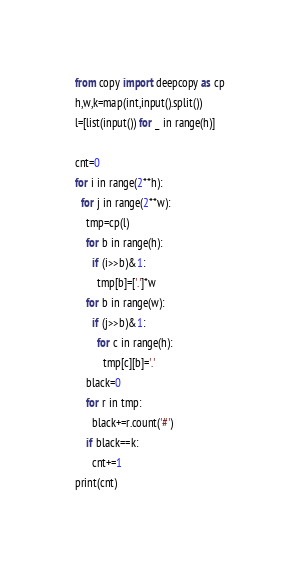Convert code to text. <code><loc_0><loc_0><loc_500><loc_500><_Python_>from copy import deepcopy as cp
h,w,k=map(int,input().split())
l=[list(input()) for _ in range(h)]

cnt=0
for i in range(2**h):
  for j in range(2**w):
    tmp=cp(l)
    for b in range(h):
      if (i>>b)&1:
        tmp[b]=['.']*w
    for b in range(w):
      if (j>>b)&1:
        for c in range(h):
          tmp[c][b]='.'
    black=0
    for r in tmp:
      black+=r.count('#')
    if black==k:
      cnt+=1
print(cnt)</code> 